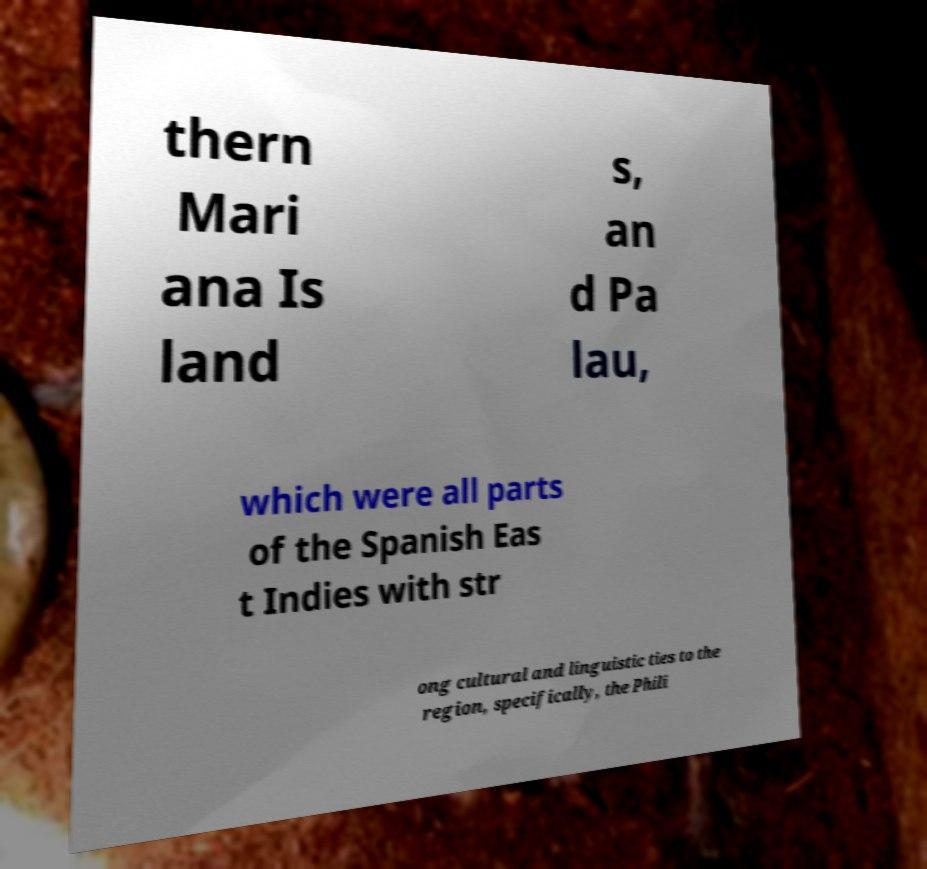For documentation purposes, I need the text within this image transcribed. Could you provide that? thern Mari ana Is land s, an d Pa lau, which were all parts of the Spanish Eas t Indies with str ong cultural and linguistic ties to the region, specifically, the Phili 